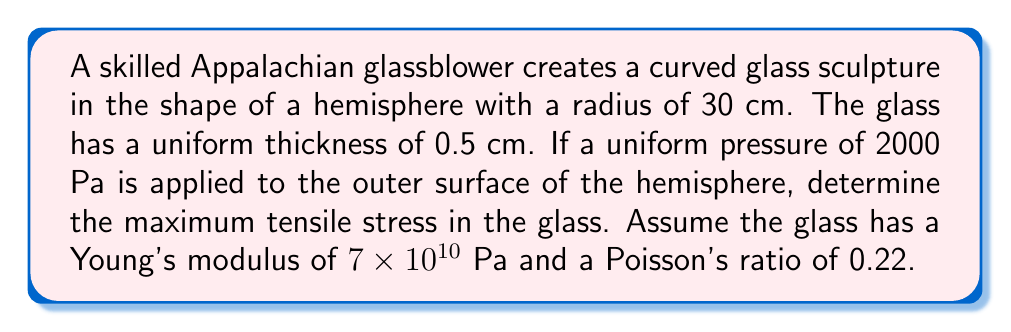Show me your answer to this math problem. To solve this problem, we'll use the thin-shell theory for a hemispherical structure. The steps are as follows:

1) First, we need to calculate the membrane stresses in the hemisphere. For a thin hemispherical shell under uniform external pressure, the meridional stress $\sigma_\phi$ and the hoop stress $\sigma_\theta$ are given by:

   $$\sigma_\phi = \sigma_\theta = -\frac{pr}{2t}$$

   where $p$ is the applied pressure, $r$ is the radius, and $t$ is the thickness.

2) Substituting the given values:
   $p = 2000$ Pa
   $r = 30$ cm $= 0.3$ m
   $t = 0.5$ cm $= 0.005$ m

   $$\sigma_\phi = \sigma_\theta = -\frac{2000 \times 0.3}{2 \times 0.005} = -60,000 \text{ Pa} = -60 \text{ kPa}$$

3) The negative sign indicates compressive stress. However, bending stresses also occur near the edges of the hemisphere, which can lead to tensile stresses.

4) The maximum bending stress occurs at the edge of the hemisphere and is given by:

   $$\sigma_b = \pm \frac{3pr}{4t} \sqrt{\frac{r}{t}}$$

5) Substituting the values:

   $$\sigma_b = \pm \frac{3 \times 2000 \times 0.3}{4 \times 0.005} \sqrt{\frac{0.3}{0.005}} = \pm 636,396 \text{ Pa} = \pm 636.4 \text{ kPa}$$

6) The total stress is the sum of the membrane stress and the bending stress. The maximum tensile stress occurs where the bending stress is positive:

   $$\sigma_{\text{max}} = -60 \text{ kPa} + 636.4 \text{ kPa} = 576.4 \text{ kPa}$$

Therefore, the maximum tensile stress in the glass is approximately 576.4 kPa.
Answer: The maximum tensile stress in the glass is 576.4 kPa. 